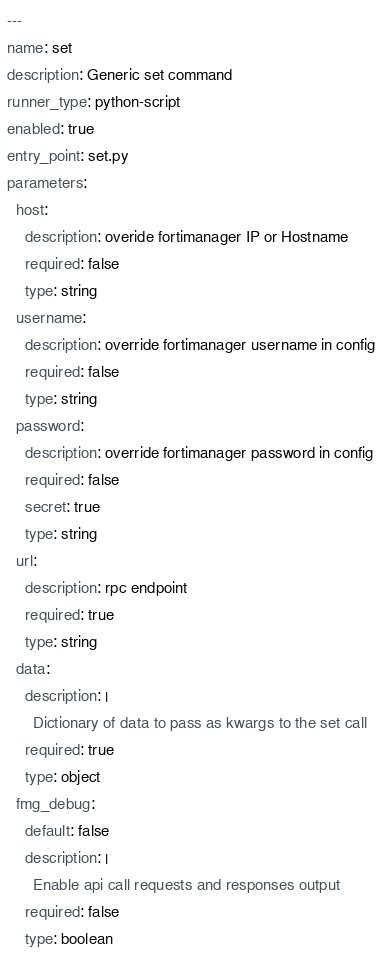Convert code to text. <code><loc_0><loc_0><loc_500><loc_500><_YAML_>---
name: set
description: Generic set command
runner_type: python-script
enabled: true
entry_point: set.py
parameters:
  host:
    description: overide fortimanager IP or Hostname
    required: false
    type: string
  username:
    description: override fortimanager username in config
    required: false
    type: string
  password:
    description: override fortimanager password in config
    required: false
    secret: true
    type: string
  url:
    description: rpc endpoint
    required: true
    type: string
  data:
    description: |
      Dictionary of data to pass as kwargs to the set call
    required: true
    type: object
  fmg_debug:
    default: false
    description: |
      Enable api call requests and responses output
    required: false
    type: boolean
</code> 